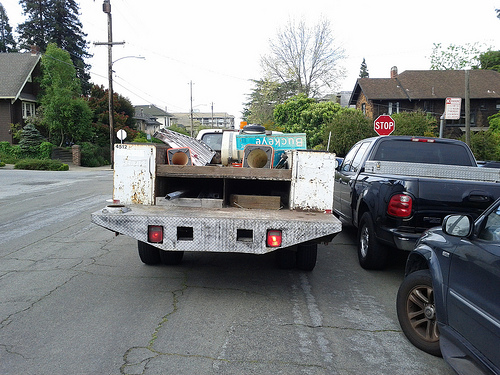How many lights are lit on the back of the white truck in the picture? 2 